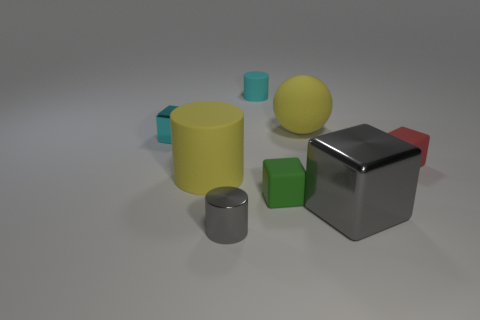There is a small object that is the same color as the big cube; what is its material?
Make the answer very short. Metal. Are there more big cubes behind the tiny gray shiny object than tiny cyan cylinders that are left of the big cylinder?
Your answer should be compact. Yes. The other small metal thing that is the same shape as the green thing is what color?
Offer a very short reply. Cyan. Do the large gray metallic thing and the gray object that is in front of the large gray metal block have the same shape?
Keep it short and to the point. No. How many other things are made of the same material as the red object?
Provide a succinct answer. 4. Does the large shiny block have the same color as the tiny cylinder on the left side of the small cyan rubber thing?
Ensure brevity in your answer.  Yes. What material is the small cylinder that is behind the large yellow rubber sphere?
Your answer should be very brief. Rubber. Is there a tiny block that has the same color as the sphere?
Keep it short and to the point. No. There is a metallic cylinder that is the same size as the cyan matte object; what color is it?
Provide a short and direct response. Gray. What number of small objects are cyan shiny things or green cubes?
Give a very brief answer. 2. 